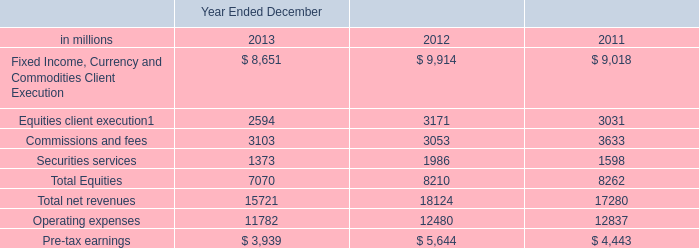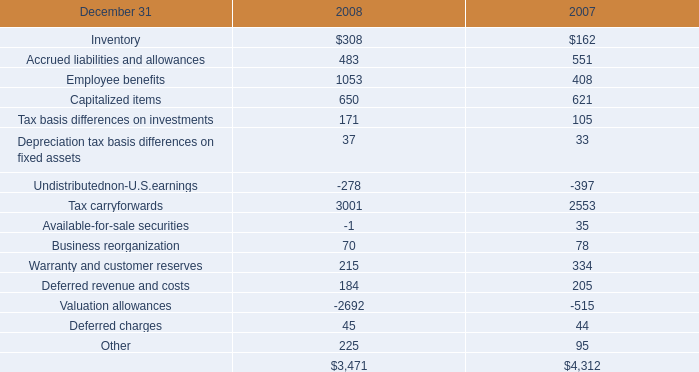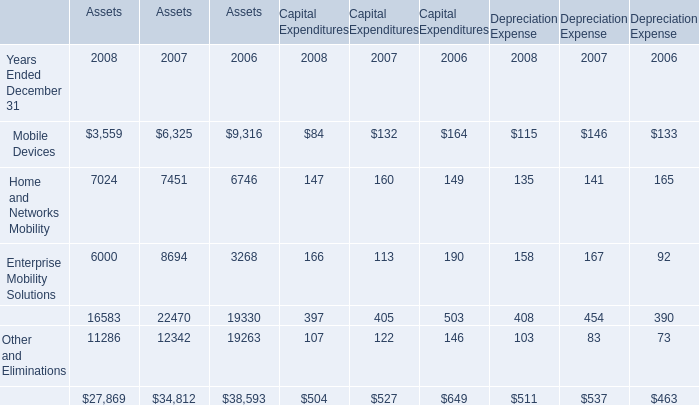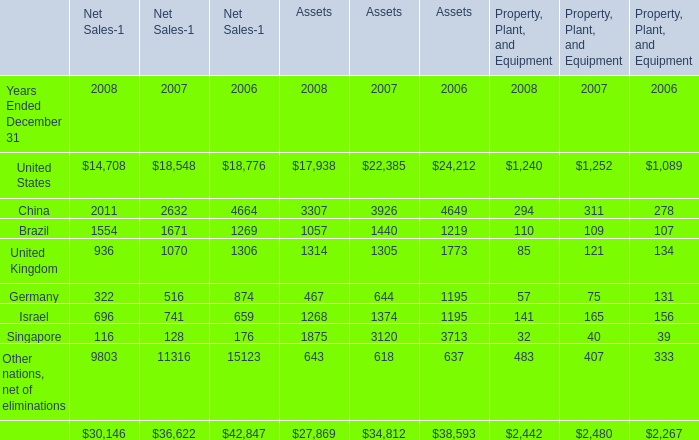What's the sum of Singapore of Assets 2006, and Securities services of Year Ended December 2011 ? 
Computations: (3713.0 + 1598.0)
Answer: 5311.0. 